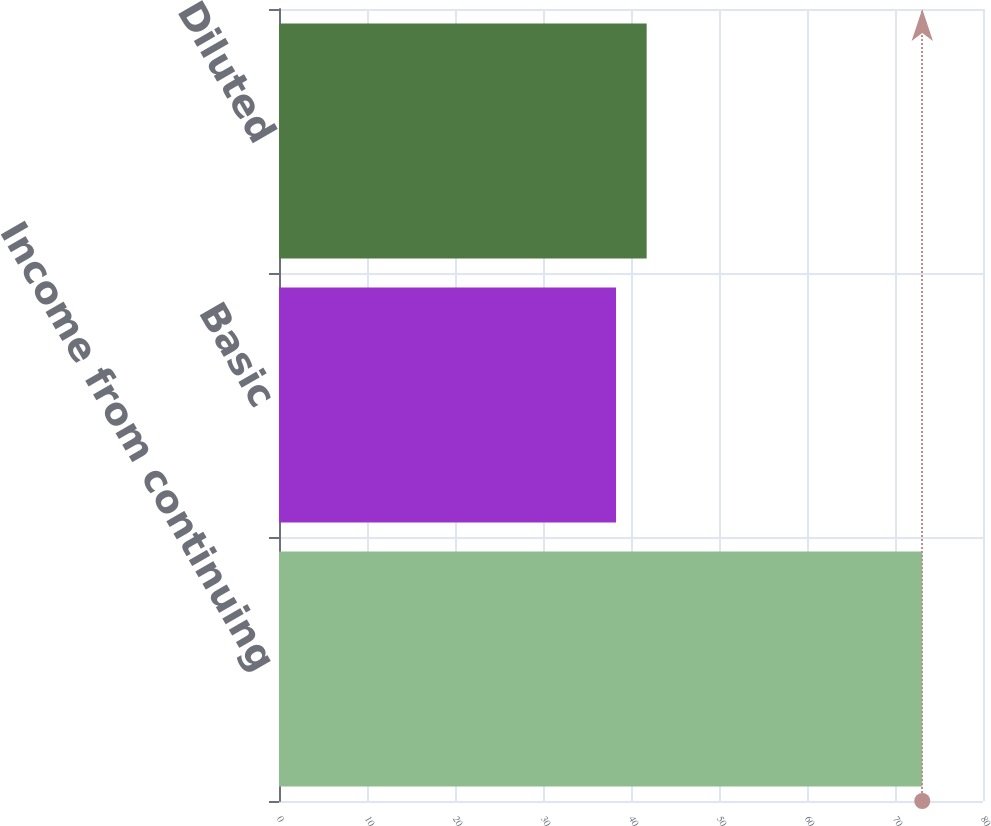<chart> <loc_0><loc_0><loc_500><loc_500><bar_chart><fcel>Income from continuing<fcel>Basic<fcel>Diluted<nl><fcel>73.1<fcel>38.3<fcel>41.78<nl></chart> 